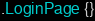<code> <loc_0><loc_0><loc_500><loc_500><_CSS_>.LoginPage {}</code> 